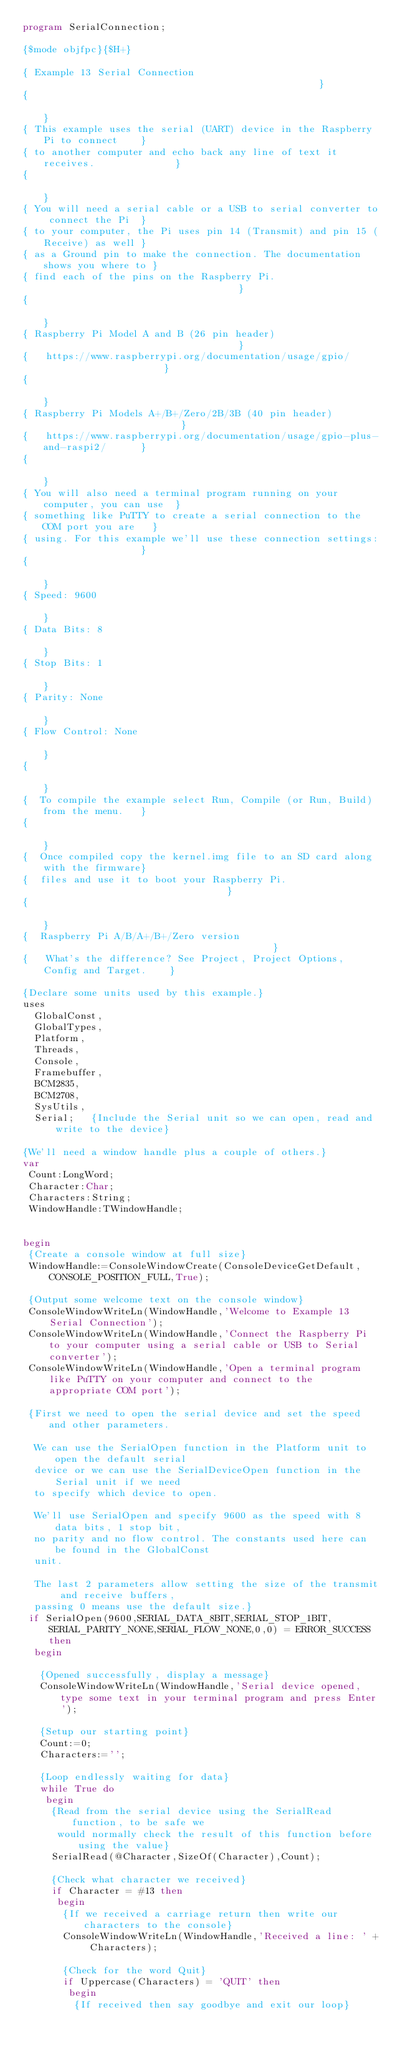Convert code to text. <code><loc_0><loc_0><loc_500><loc_500><_Pascal_>program SerialConnection;

{$mode objfpc}{$H+}

{ Example 13 Serial Connection                                                 }
{                                                                              }
{ This example uses the serial (UART) device in the Raspberry Pi to connect    }
{ to another computer and echo back any line of text it receives.              }
{                                                                              }
{ You will need a serial cable or a USB to serial converter to connect the Pi  }
{ to your computer, the Pi uses pin 14 (Transmit) and pin 15 (Receive) as well }
{ as a Ground pin to make the connection. The documentation shows you where to }
{ find each of the pins on the Raspberry Pi.                                   }
{                                                                              }
{ Raspberry Pi Model A and B (26 pin header)                                   }
{   https://www.raspberrypi.org/documentation/usage/gpio/                      }
{                                                                              }
{ Raspberry Pi Models A+/B+/Zero/2B/3B (40 pin header)                         }
{   https://www.raspberrypi.org/documentation/usage/gpio-plus-and-raspi2/      }
{                                                                              }
{ You will also need a terminal program running on your computer, you can use  }
{ something like PuTTY to create a serial connection to the COM port you are   }
{ using. For this example we'll use these connection settings:                 }
{                                                                              }
{ Speed: 9600                                                                  }
{ Data Bits: 8                                                                 }
{ Stop Bits: 1                                                                 }
{ Parity: None                                                                 }
{ Flow Control: None                                                           }
{                                                                              }
{  To compile the example select Run, Compile (or Run, Build) from the menu.   }
{                                                                              }
{  Once compiled copy the kernel.img file to an SD card along with the firmware}
{  files and use it to boot your Raspberry Pi.                                 }
{                                                                              }
{  Raspberry Pi A/B/A+/B+/Zero version                                         }
{   What's the difference? See Project, Project Options, Config and Target.    }

{Declare some units used by this example.}
uses
  GlobalConst,
  GlobalTypes,
  Platform,
  Threads,
  Console,
  Framebuffer,
  BCM2835,
  BCM2708,
  SysUtils,
  Serial;   {Include the Serial unit so we can open, read and write to the device}

{We'll need a window handle plus a couple of others.}
var
 Count:LongWord;
 Character:Char;
 Characters:String;
 WindowHandle:TWindowHandle;


begin
 {Create a console window at full size}
 WindowHandle:=ConsoleWindowCreate(ConsoleDeviceGetDefault,CONSOLE_POSITION_FULL,True);

 {Output some welcome text on the console window}
 ConsoleWindowWriteLn(WindowHandle,'Welcome to Example 13 Serial Connection');
 ConsoleWindowWriteLn(WindowHandle,'Connect the Raspberry Pi to your computer using a serial cable or USB to Serial converter');
 ConsoleWindowWriteLn(WindowHandle,'Open a terminal program like PuTTY on your computer and connect to the appropriate COM port');

 {First we need to open the serial device and set the speed and other parameters.

  We can use the SerialOpen function in the Platform unit to open the default serial
  device or we can use the SerialDeviceOpen function in the Serial unit if we need
  to specify which device to open.

  We'll use SerialOpen and specify 9600 as the speed with 8 data bits, 1 stop bit,
  no parity and no flow control. The constants used here can be found in the GlobalConst
  unit.

  The last 2 parameters allow setting the size of the transmit and receive buffers,
  passing 0 means use the default size.}
 if SerialOpen(9600,SERIAL_DATA_8BIT,SERIAL_STOP_1BIT,SERIAL_PARITY_NONE,SERIAL_FLOW_NONE,0,0) = ERROR_SUCCESS then
  begin

   {Opened successfully, display a message}
   ConsoleWindowWriteLn(WindowHandle,'Serial device opened, type some text in your terminal program and press Enter');

   {Setup our starting point}
   Count:=0;
   Characters:='';

   {Loop endlessly waiting for data}
   while True do
    begin
     {Read from the serial device using the SerialRead function, to be safe we
      would normally check the result of this function before using the value}
     SerialRead(@Character,SizeOf(Character),Count);

     {Check what character we received}
     if Character = #13 then
      begin
       {If we received a carriage return then write our characters to the console}
       ConsoleWindowWriteLn(WindowHandle,'Received a line: ' + Characters);

       {Check for the word Quit}
       if Uppercase(Characters) = 'QUIT' then
        begin
         {If received then say goodbye and exit our loop}</code> 